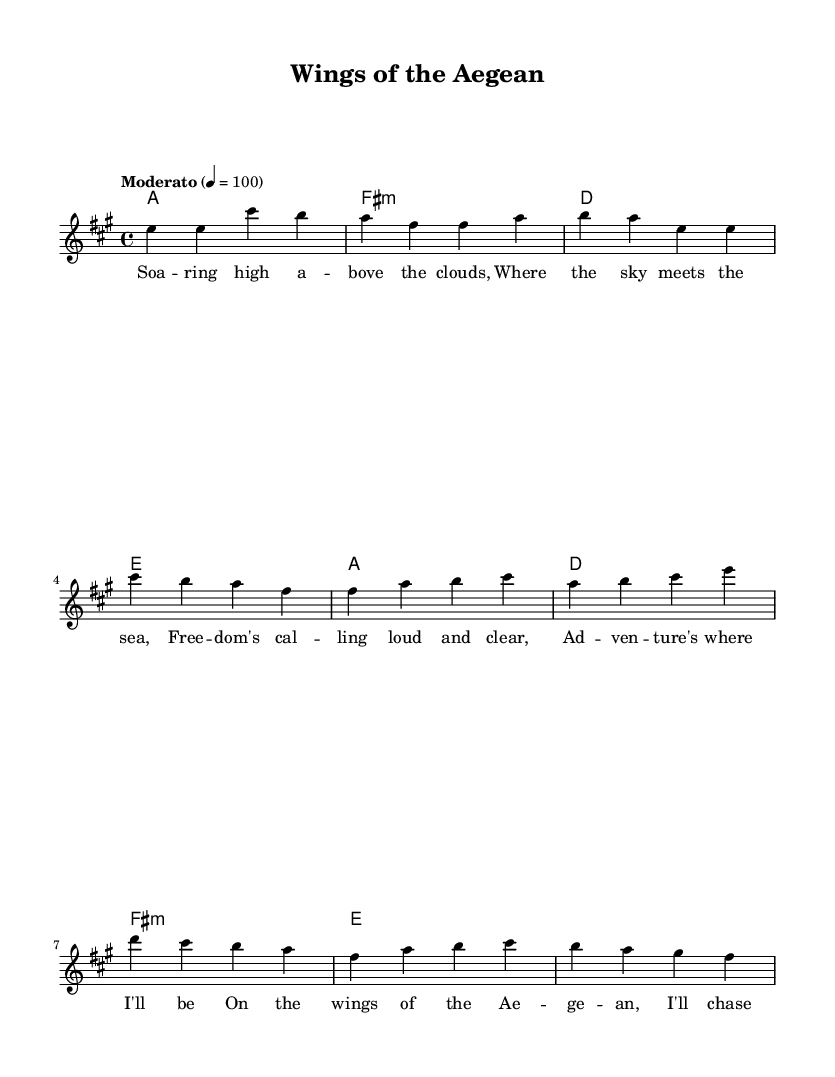What is the key signature of this music? The key signature is indicated at the beginning of the music. The note layout shows three sharps (F#, C#, and G#), which identify the key as A major.
Answer: A major What is the time signature of this music? The time signature is found at the beginning of the score and indicates how many beats are in each measure. Here, it shows 4/4, meaning there are four quarter-note beats per measure.
Answer: 4/4 What is the tempo marking for this music? The tempo marking is usually given above the staff; it shows that the piece should be played at a moderate speed, specifically at 100 beats per minute.
Answer: Moderato, 100 How many measures are in the verse section? By counting the distinct sections in the melody part marked as verse, we find there are six measures in this section.
Answer: Six What is the first note of the chorus? The first note of the chorus can be found by looking at the melody line right after the verse. It starts on an A.
Answer: A What is the last chord in the piece? The final chord can be identified at the end of the score within the harmonies section. The last chord shown is E major.
Answer: E What is the theme of the song as indicated by the lyrics? The lyrics describe themes of freedom and adventure, specifically mentioning chasing the sun and having no boundaries, suggesting a quest for exploration.
Answer: Freedom and adventure 